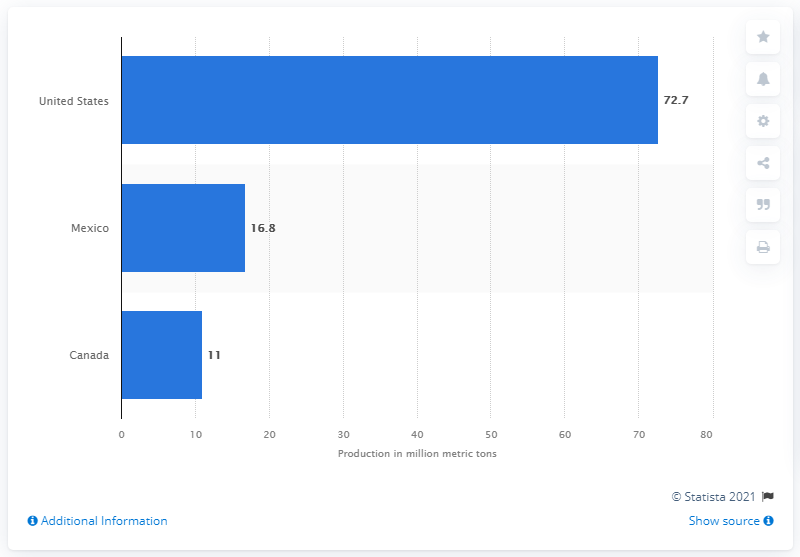List a handful of essential elements in this visual. In 2020, the United States produced 72.7 million metric tons of crude steel. 